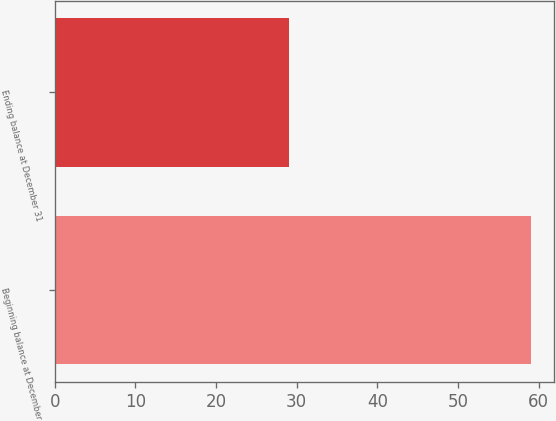Convert chart to OTSL. <chart><loc_0><loc_0><loc_500><loc_500><bar_chart><fcel>Beginning balance at December<fcel>Ending balance at December 31<nl><fcel>59<fcel>29<nl></chart> 